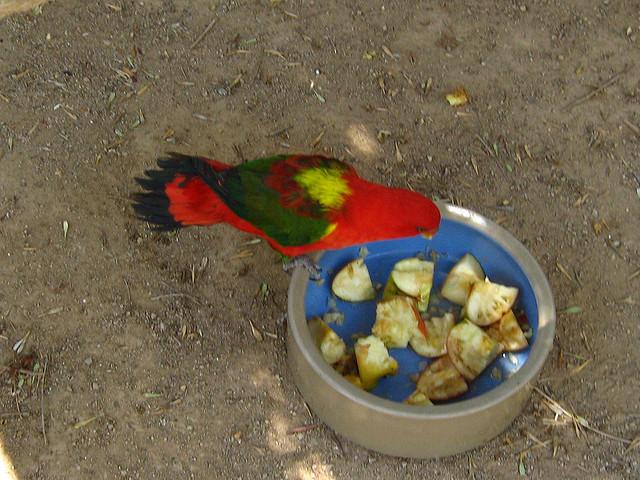Is the bird purple?
Write a very short answer. No. What kind of food is the bird eating?
Write a very short answer. Fruit. What is the bird doing?
Concise answer only. Eating. 